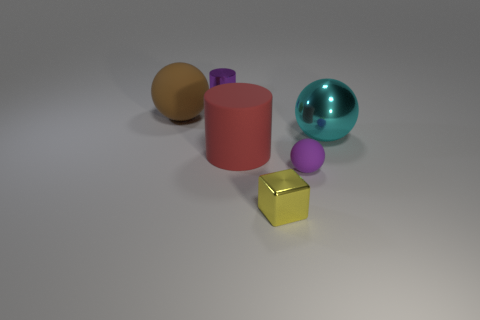Subtract all purple matte balls. How many balls are left? 2 Add 4 tiny rubber spheres. How many objects exist? 10 Subtract all purple spheres. How many spheres are left? 2 Subtract 1 cylinders. How many cylinders are left? 1 Subtract all cubes. How many objects are left? 5 Add 6 tiny green metal cubes. How many tiny green metal cubes exist? 6 Subtract 1 cyan spheres. How many objects are left? 5 Subtract all green blocks. Subtract all brown cylinders. How many blocks are left? 1 Subtract all small metal cylinders. Subtract all tiny matte things. How many objects are left? 4 Add 5 purple matte things. How many purple matte things are left? 6 